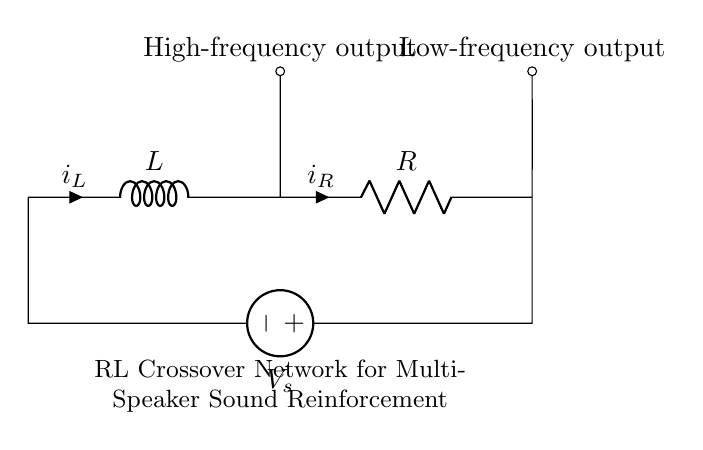What is the type of inductor in this circuit? The circuit diagram shows a standard inductor symbol, indicated by "L".
Answer: Inductor What is the output labeled for high frequencies? The high-frequency output is indicated by a label above the point where the inductor connects to the circuit.
Answer: High-frequency output What is the total load of this circuit? The circuit consists of an inductor and a resistor in series, with their values determining the total load, but the individual values are not specified in the diagram.
Answer: Not specified What component comes before the resistor in the circuit? The diagram shows that the inductor is connected before the resistor in series.
Answer: Inductor How many outputs are shown in the circuit? The circuit diagram clearly labels two outputs: one for high frequency and one for low frequency.
Answer: Two outputs Which component affects the low-frequency response? The resistor, connected in series after the inductor, is responsible for determining the low-frequency response of the circuit.
Answer: Resistor What is the main function of this RL circuit in sound reinforcement? The RL circuit is designed to separate frequencies for multi-speaker setups, with the inductor allowing high frequencies to pass while the resistor affects the low frequencies.
Answer: Crossover 